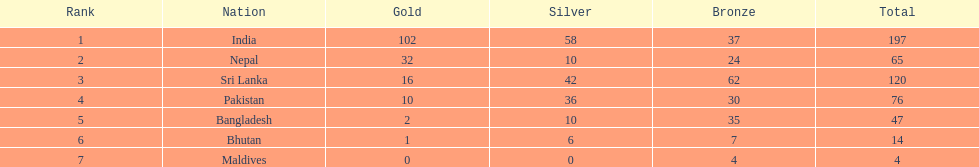Could you help me parse every detail presented in this table? {'header': ['Rank', 'Nation', 'Gold', 'Silver', 'Bronze', 'Total'], 'rows': [['1', 'India', '102', '58', '37', '197'], ['2', 'Nepal', '32', '10', '24', '65'], ['3', 'Sri Lanka', '16', '42', '62', '120'], ['4', 'Pakistan', '10', '36', '30', '76'], ['5', 'Bangladesh', '2', '10', '35', '47'], ['6', 'Bhutan', '1', '6', '7', '14'], ['7', 'Maldives', '0', '0', '4', '4']]} How many more gold medals has nepal won than pakistan? 22. 